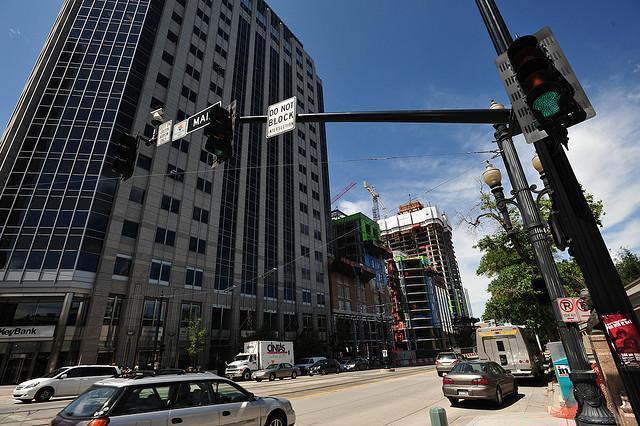How many cars are there?
Give a very brief answer. 3. How many horses are there?
Give a very brief answer. 0. 